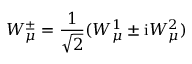Convert formula to latex. <formula><loc_0><loc_0><loc_500><loc_500>W _ { \mu } ^ { \pm } = \frac { 1 } { \sqrt { 2 } } ( W _ { \mu } ^ { 1 } \pm i W _ { \mu } ^ { 2 } )</formula> 